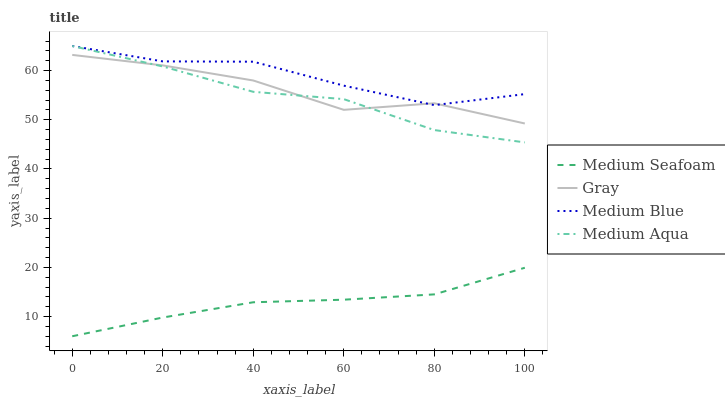Does Medium Seafoam have the minimum area under the curve?
Answer yes or no. Yes. Does Medium Blue have the maximum area under the curve?
Answer yes or no. Yes. Does Gray have the minimum area under the curve?
Answer yes or no. No. Does Gray have the maximum area under the curve?
Answer yes or no. No. Is Medium Seafoam the smoothest?
Answer yes or no. Yes. Is Gray the roughest?
Answer yes or no. Yes. Is Medium Blue the smoothest?
Answer yes or no. No. Is Medium Blue the roughest?
Answer yes or no. No. Does Gray have the lowest value?
Answer yes or no. No. Does Medium Blue have the highest value?
Answer yes or no. Yes. Does Gray have the highest value?
Answer yes or no. No. Is Medium Seafoam less than Medium Blue?
Answer yes or no. Yes. Is Medium Blue greater than Medium Seafoam?
Answer yes or no. Yes. Does Medium Aqua intersect Gray?
Answer yes or no. Yes. Is Medium Aqua less than Gray?
Answer yes or no. No. Is Medium Aqua greater than Gray?
Answer yes or no. No. Does Medium Seafoam intersect Medium Blue?
Answer yes or no. No. 